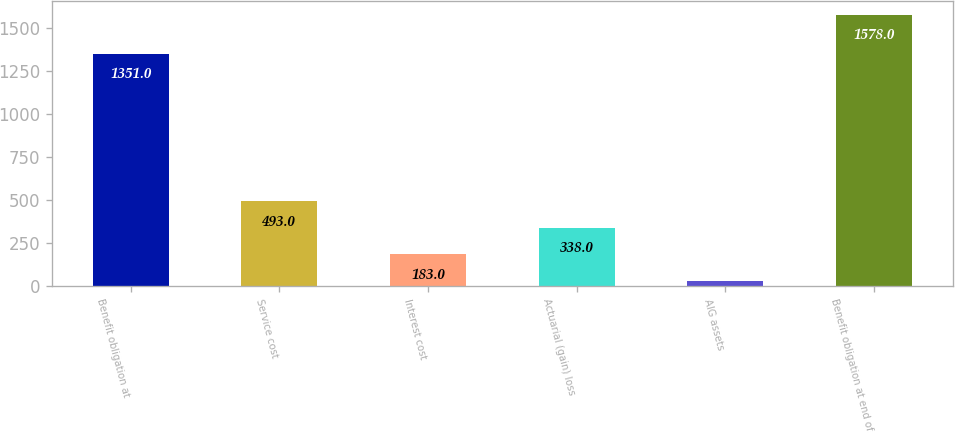Convert chart. <chart><loc_0><loc_0><loc_500><loc_500><bar_chart><fcel>Benefit obligation at<fcel>Service cost<fcel>Interest cost<fcel>Actuarial (gain) loss<fcel>AIG assets<fcel>Benefit obligation at end of<nl><fcel>1351<fcel>493<fcel>183<fcel>338<fcel>28<fcel>1578<nl></chart> 